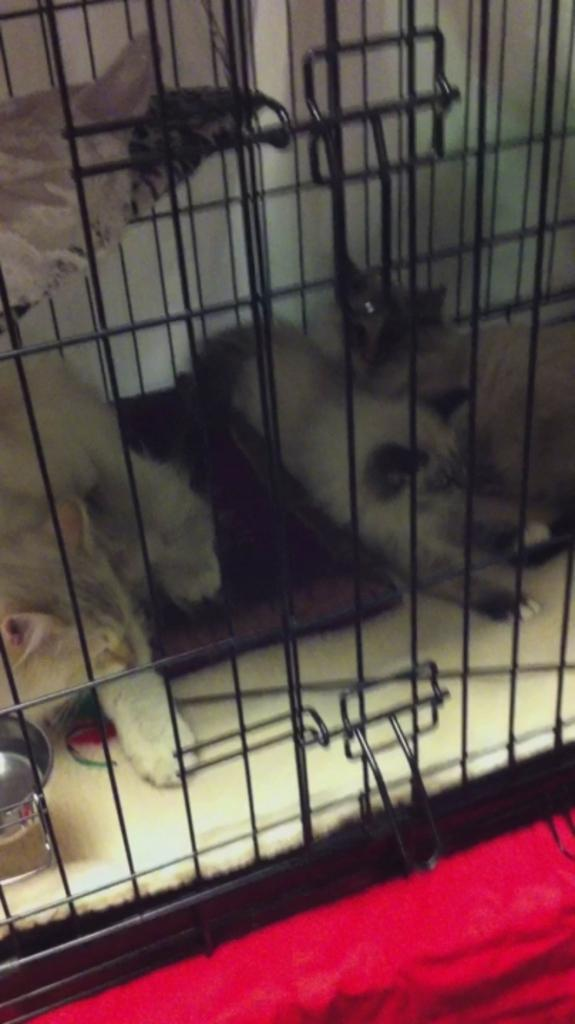What is located in the center of the image? There is a cage in the center of the image. What animals are inside the cage? There are cats in the cage. Can you describe the cats in the cage? The cats are in different colors. What is present at the bottom of the image? There is a red cloth at the bottom of the image. Where is the unit located in the image? There is no unit mentioned or visible in the image. Can you describe the cellar in the image? There is no cellar present in the image. 